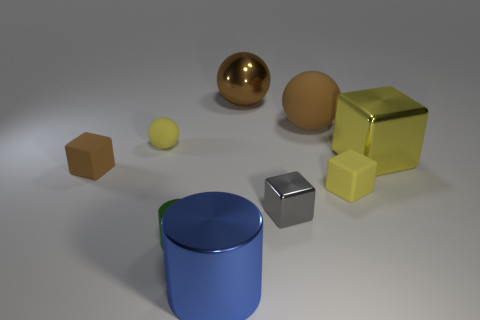What is the shape of the large metal object right of the tiny matte block that is on the right side of the tiny rubber block left of the gray block?
Offer a very short reply. Cube. What is the shape of the thing that is in front of the small yellow rubber cube and right of the blue object?
Your answer should be very brief. Cube. Is there a big object made of the same material as the yellow ball?
Ensure brevity in your answer.  Yes. The matte sphere that is the same color as the large shiny ball is what size?
Provide a succinct answer. Large. What color is the small metallic thing in front of the gray metallic thing?
Give a very brief answer. Green. Is the shape of the yellow metallic thing the same as the tiny brown thing in front of the large shiny ball?
Your response must be concise. Yes. Are there any tiny shiny cylinders that have the same color as the large cylinder?
Keep it short and to the point. No. What is the size of the sphere that is the same material as the tiny cylinder?
Ensure brevity in your answer.  Large. Is the color of the large rubber object the same as the metal ball?
Offer a terse response. Yes. Does the brown matte thing that is to the left of the large brown metallic sphere have the same shape as the small gray metal object?
Your response must be concise. Yes. 